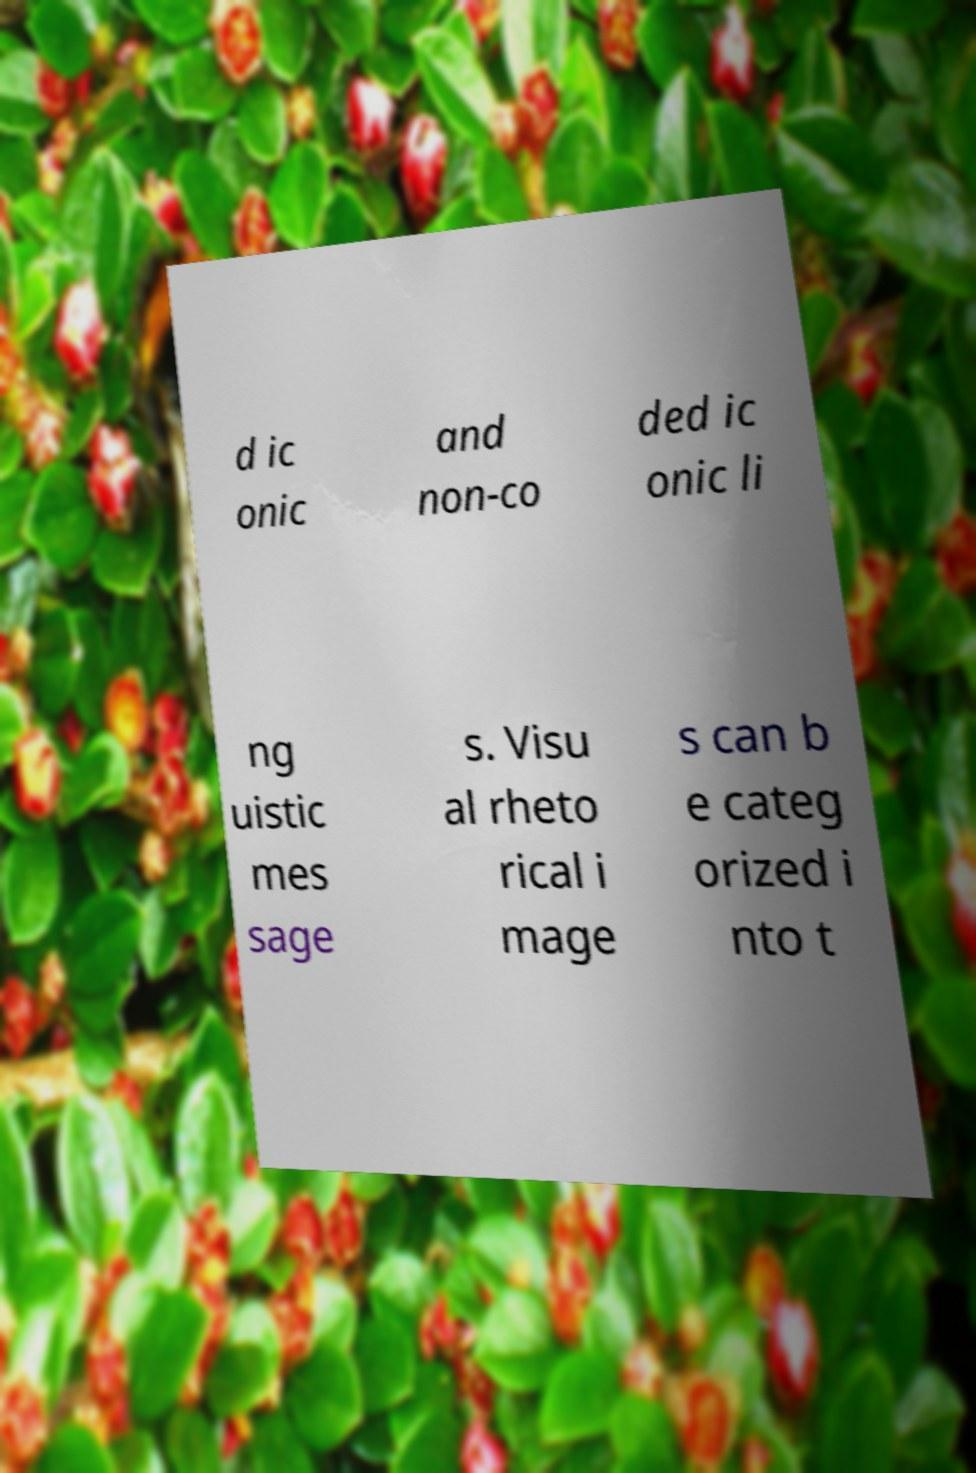Please read and relay the text visible in this image. What does it say? d ic onic and non-co ded ic onic li ng uistic mes sage s. Visu al rheto rical i mage s can b e categ orized i nto t 